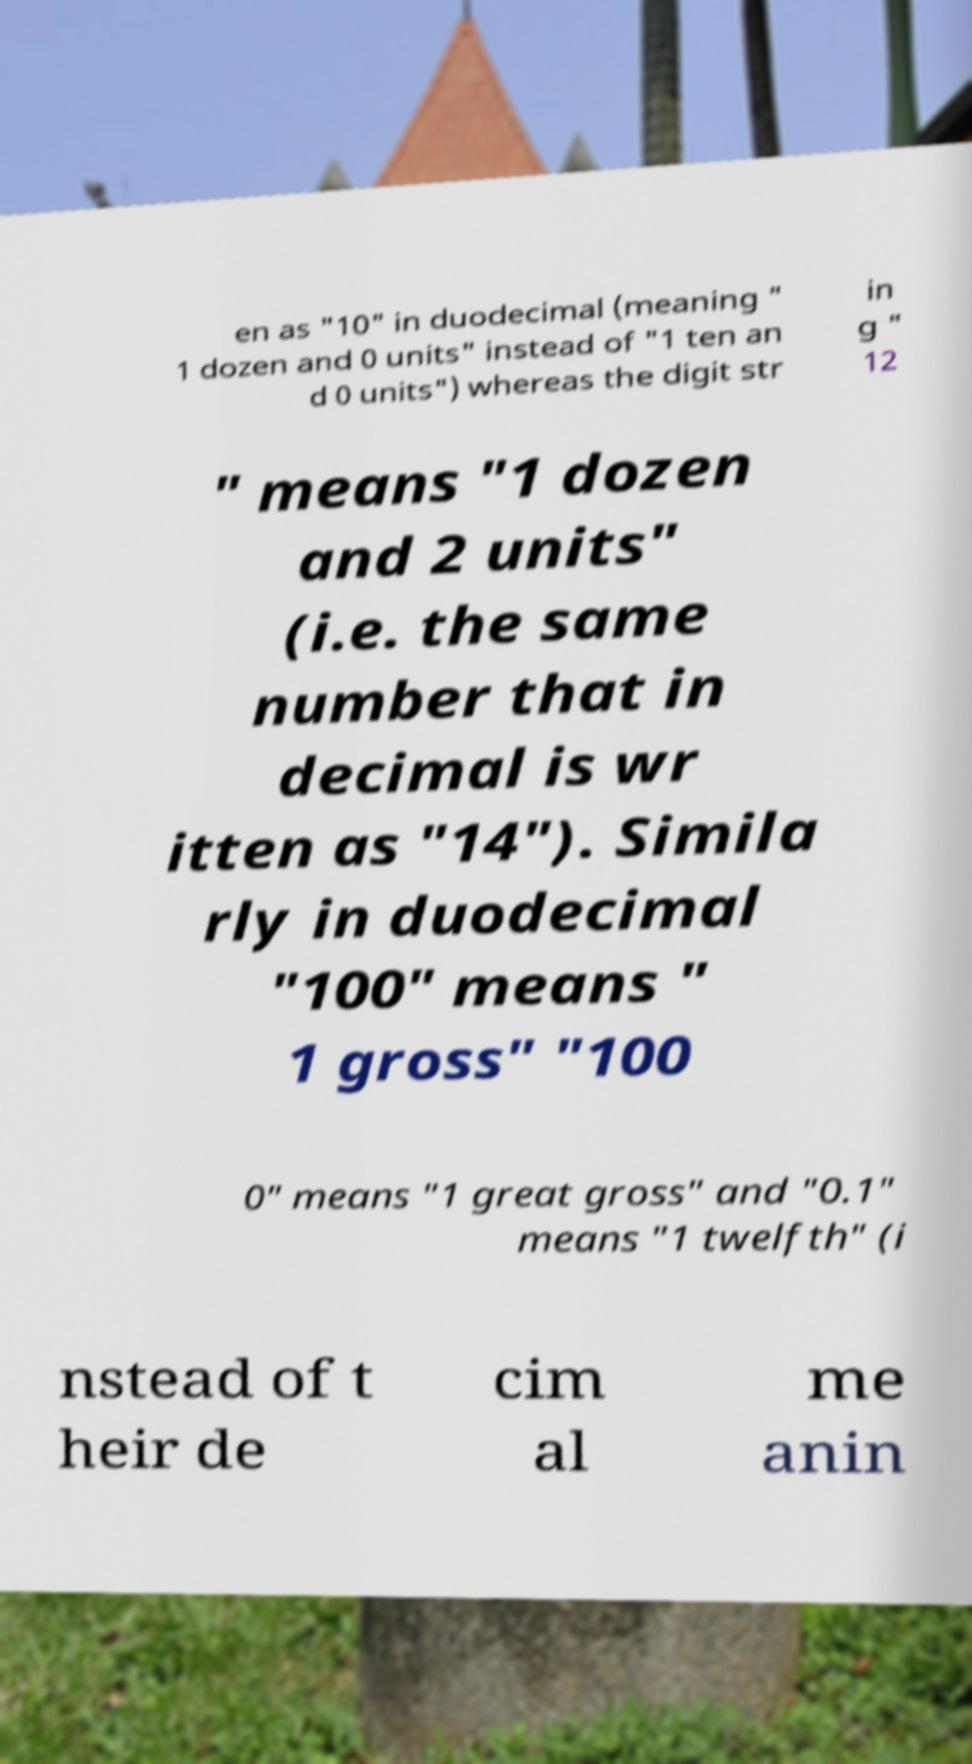Can you read and provide the text displayed in the image?This photo seems to have some interesting text. Can you extract and type it out for me? en as "10" in duodecimal (meaning " 1 dozen and 0 units" instead of "1 ten an d 0 units") whereas the digit str in g " 12 " means "1 dozen and 2 units" (i.e. the same number that in decimal is wr itten as "14"). Simila rly in duodecimal "100" means " 1 gross" "100 0" means "1 great gross" and "0.1" means "1 twelfth" (i nstead of t heir de cim al me anin 